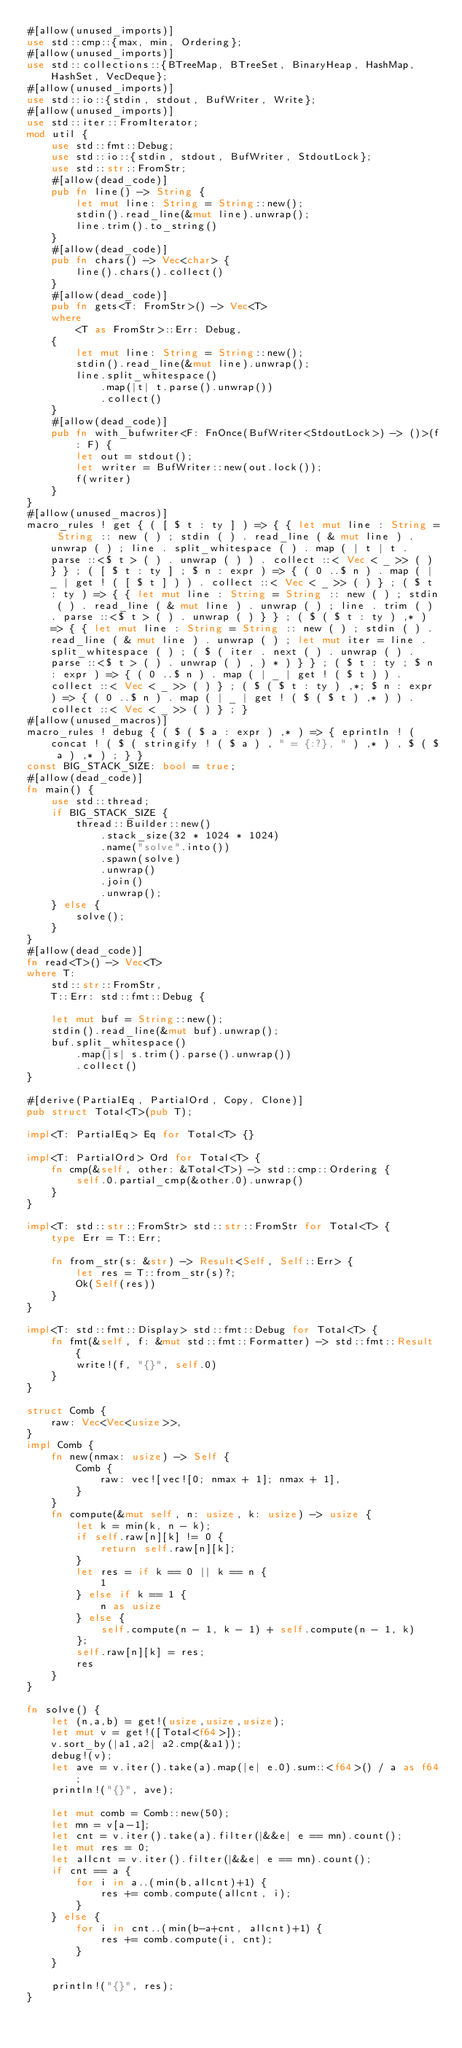Convert code to text. <code><loc_0><loc_0><loc_500><loc_500><_Rust_>#[allow(unused_imports)]
use std::cmp::{max, min, Ordering};
#[allow(unused_imports)]
use std::collections::{BTreeMap, BTreeSet, BinaryHeap, HashMap, HashSet, VecDeque};
#[allow(unused_imports)]
use std::io::{stdin, stdout, BufWriter, Write};
#[allow(unused_imports)]
use std::iter::FromIterator;
mod util {
    use std::fmt::Debug;
    use std::io::{stdin, stdout, BufWriter, StdoutLock};
    use std::str::FromStr;
    #[allow(dead_code)]
    pub fn line() -> String {
        let mut line: String = String::new();
        stdin().read_line(&mut line).unwrap();
        line.trim().to_string()
    }
    #[allow(dead_code)]
    pub fn chars() -> Vec<char> {
        line().chars().collect()
    }
    #[allow(dead_code)]
    pub fn gets<T: FromStr>() -> Vec<T>
    where
        <T as FromStr>::Err: Debug,
    {
        let mut line: String = String::new();
        stdin().read_line(&mut line).unwrap();
        line.split_whitespace()
            .map(|t| t.parse().unwrap())
            .collect()
    }
    #[allow(dead_code)]
    pub fn with_bufwriter<F: FnOnce(BufWriter<StdoutLock>) -> ()>(f: F) {
        let out = stdout();
        let writer = BufWriter::new(out.lock());
        f(writer)
    }
}
#[allow(unused_macros)]
macro_rules ! get { ( [ $ t : ty ] ) => { { let mut line : String = String :: new ( ) ; stdin ( ) . read_line ( & mut line ) . unwrap ( ) ; line . split_whitespace ( ) . map ( | t | t . parse ::<$ t > ( ) . unwrap ( ) ) . collect ::< Vec < _ >> ( ) } } ; ( [ $ t : ty ] ; $ n : expr ) => { ( 0 ..$ n ) . map ( | _ | get ! ( [ $ t ] ) ) . collect ::< Vec < _ >> ( ) } ; ( $ t : ty ) => { { let mut line : String = String :: new ( ) ; stdin ( ) . read_line ( & mut line ) . unwrap ( ) ; line . trim ( ) . parse ::<$ t > ( ) . unwrap ( ) } } ; ( $ ( $ t : ty ) ,* ) => { { let mut line : String = String :: new ( ) ; stdin ( ) . read_line ( & mut line ) . unwrap ( ) ; let mut iter = line . split_whitespace ( ) ; ( $ ( iter . next ( ) . unwrap ( ) . parse ::<$ t > ( ) . unwrap ( ) , ) * ) } } ; ( $ t : ty ; $ n : expr ) => { ( 0 ..$ n ) . map ( | _ | get ! ( $ t ) ) . collect ::< Vec < _ >> ( ) } ; ( $ ( $ t : ty ) ,*; $ n : expr ) => { ( 0 ..$ n ) . map ( | _ | get ! ( $ ( $ t ) ,* ) ) . collect ::< Vec < _ >> ( ) } ; }
#[allow(unused_macros)]
macro_rules ! debug { ( $ ( $ a : expr ) ,* ) => { eprintln ! ( concat ! ( $ ( stringify ! ( $ a ) , " = {:?}, " ) ,* ) , $ ( $ a ) ,* ) ; } }
const BIG_STACK_SIZE: bool = true;
#[allow(dead_code)]
fn main() {
    use std::thread;
    if BIG_STACK_SIZE {
        thread::Builder::new()
            .stack_size(32 * 1024 * 1024)
            .name("solve".into())
            .spawn(solve)
            .unwrap()
            .join()
            .unwrap();
    } else {
        solve();
    }
}
#[allow(dead_code)]
fn read<T>() -> Vec<T>
where T:
    std::str::FromStr,
    T::Err: std::fmt::Debug {

    let mut buf = String::new();
    stdin().read_line(&mut buf).unwrap();
    buf.split_whitespace()
        .map(|s| s.trim().parse().unwrap())
        .collect()
}

#[derive(PartialEq, PartialOrd, Copy, Clone)]
pub struct Total<T>(pub T);

impl<T: PartialEq> Eq for Total<T> {}

impl<T: PartialOrd> Ord for Total<T> {
    fn cmp(&self, other: &Total<T>) -> std::cmp::Ordering {
        self.0.partial_cmp(&other.0).unwrap()
    }
}

impl<T: std::str::FromStr> std::str::FromStr for Total<T> {
    type Err = T::Err;

    fn from_str(s: &str) -> Result<Self, Self::Err> {
        let res = T::from_str(s)?;
        Ok(Self(res))
    }
}

impl<T: std::fmt::Display> std::fmt::Debug for Total<T> {
    fn fmt(&self, f: &mut std::fmt::Formatter) -> std::fmt::Result {
        write!(f, "{}", self.0)
    }
}

struct Comb {
    raw: Vec<Vec<usize>>,
}
impl Comb {
    fn new(nmax: usize) -> Self {
        Comb {
            raw: vec![vec![0; nmax + 1]; nmax + 1],
        }
    }
    fn compute(&mut self, n: usize, k: usize) -> usize {
        let k = min(k, n - k);
        if self.raw[n][k] != 0 {
            return self.raw[n][k];
        }
        let res = if k == 0 || k == n {
            1
        } else if k == 1 {
            n as usize
        } else {
            self.compute(n - 1, k - 1) + self.compute(n - 1, k)
        };
        self.raw[n][k] = res;
        res
    }
}

fn solve() {
    let (n,a,b) = get!(usize,usize,usize);
    let mut v = get!([Total<f64>]);
    v.sort_by(|a1,a2| a2.cmp(&a1));
    debug!(v);
    let ave = v.iter().take(a).map(|e| e.0).sum::<f64>() / a as f64;
    println!("{}", ave);

    let mut comb = Comb::new(50);
    let mn = v[a-1];
    let cnt = v.iter().take(a).filter(|&&e| e == mn).count();
    let mut res = 0;
    let allcnt = v.iter().filter(|&&e| e == mn).count();
    if cnt == a {
        for i in a..(min(b,allcnt)+1) {
            res += comb.compute(allcnt, i);
        }
    } else {
        for i in cnt..(min(b-a+cnt, allcnt)+1) {
            res += comb.compute(i, cnt);
        }
    }

    println!("{}", res);
}
</code> 